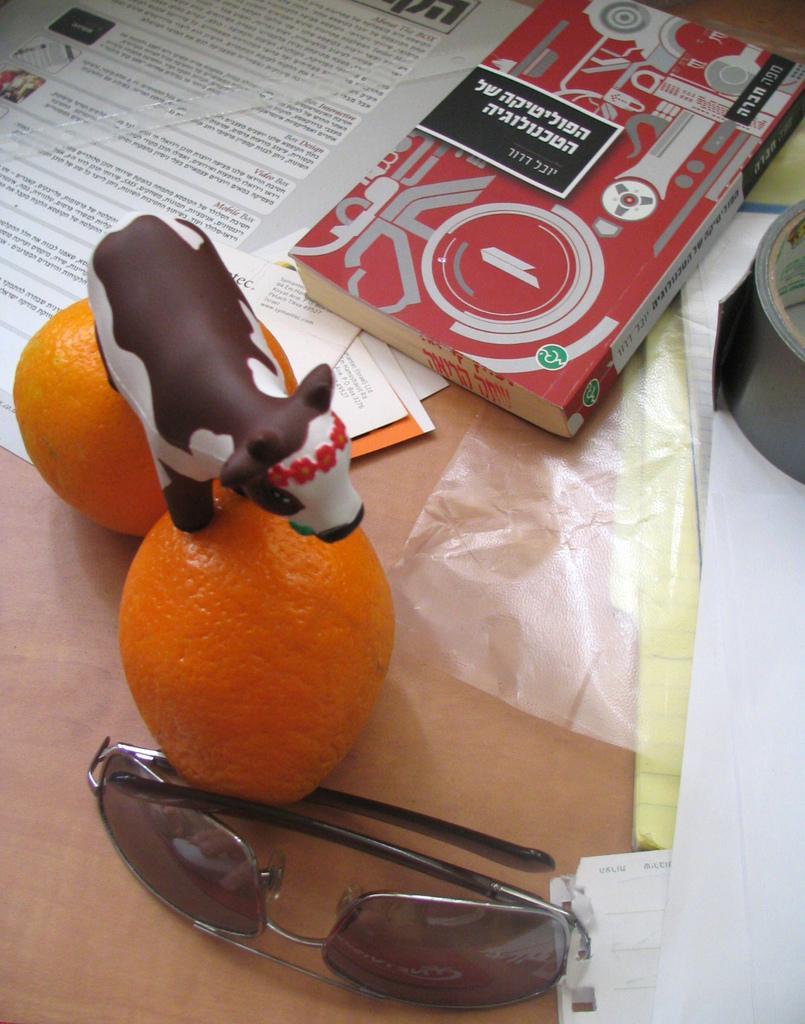Describe this image in one or two sentences. This image consists of books, papers, goggles, two oranges and a toy cow may be kept on the table. This image is taken may be in a room. 